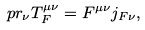Convert formula to latex. <formula><loc_0><loc_0><loc_500><loc_500>\ p r _ { \nu } T _ { F } ^ { \mu \nu } = F ^ { \mu \nu } j _ { F \nu } ,</formula> 